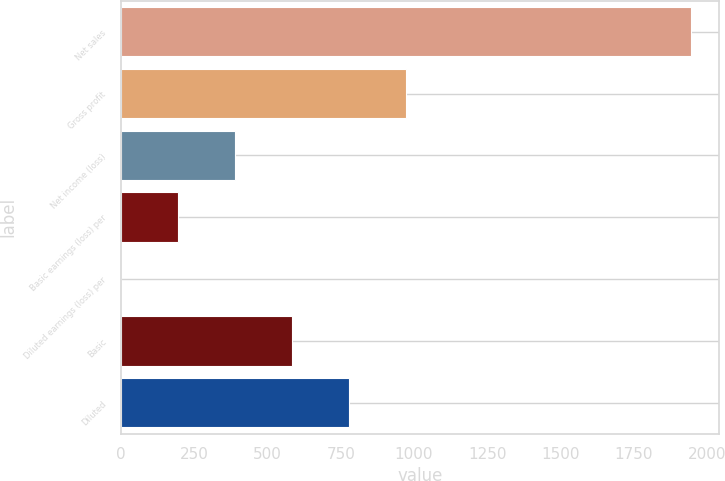<chart> <loc_0><loc_0><loc_500><loc_500><bar_chart><fcel>Net sales<fcel>Gross profit<fcel>Net income (loss)<fcel>Basic earnings (loss) per<fcel>Diluted earnings (loss) per<fcel>Basic<fcel>Diluted<nl><fcel>1946<fcel>973.07<fcel>389.33<fcel>194.75<fcel>0.17<fcel>583.91<fcel>778.49<nl></chart> 